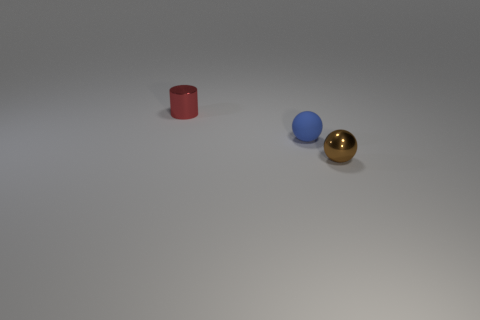There is a metallic thing behind the metal object that is in front of the metal object behind the small brown metal thing; what is its shape?
Your answer should be very brief. Cylinder. What number of other objects are there of the same shape as the small brown metallic thing?
Your response must be concise. 1. There is a shiny thing that is the same size as the brown shiny sphere; what is its color?
Your answer should be very brief. Red. How many cylinders are either big cyan matte things or small red objects?
Your answer should be compact. 1. How many metallic spheres are there?
Make the answer very short. 1. Do the tiny rubber thing and the small shiny object that is behind the tiny brown object have the same shape?
Provide a succinct answer. No. What number of objects are either tiny brown spheres or cylinders?
Keep it short and to the point. 2. The small metallic thing that is behind the shiny thing that is in front of the blue rubber sphere is what shape?
Provide a short and direct response. Cylinder. There is a blue rubber object that is to the left of the tiny brown shiny thing; does it have the same shape as the brown metal thing?
Give a very brief answer. Yes. How many objects are small objects that are right of the small metallic cylinder or tiny metal things that are in front of the red cylinder?
Provide a succinct answer. 2. 